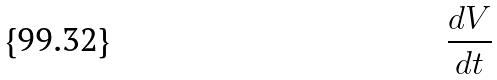<formula> <loc_0><loc_0><loc_500><loc_500>\frac { d V } { d t }</formula> 